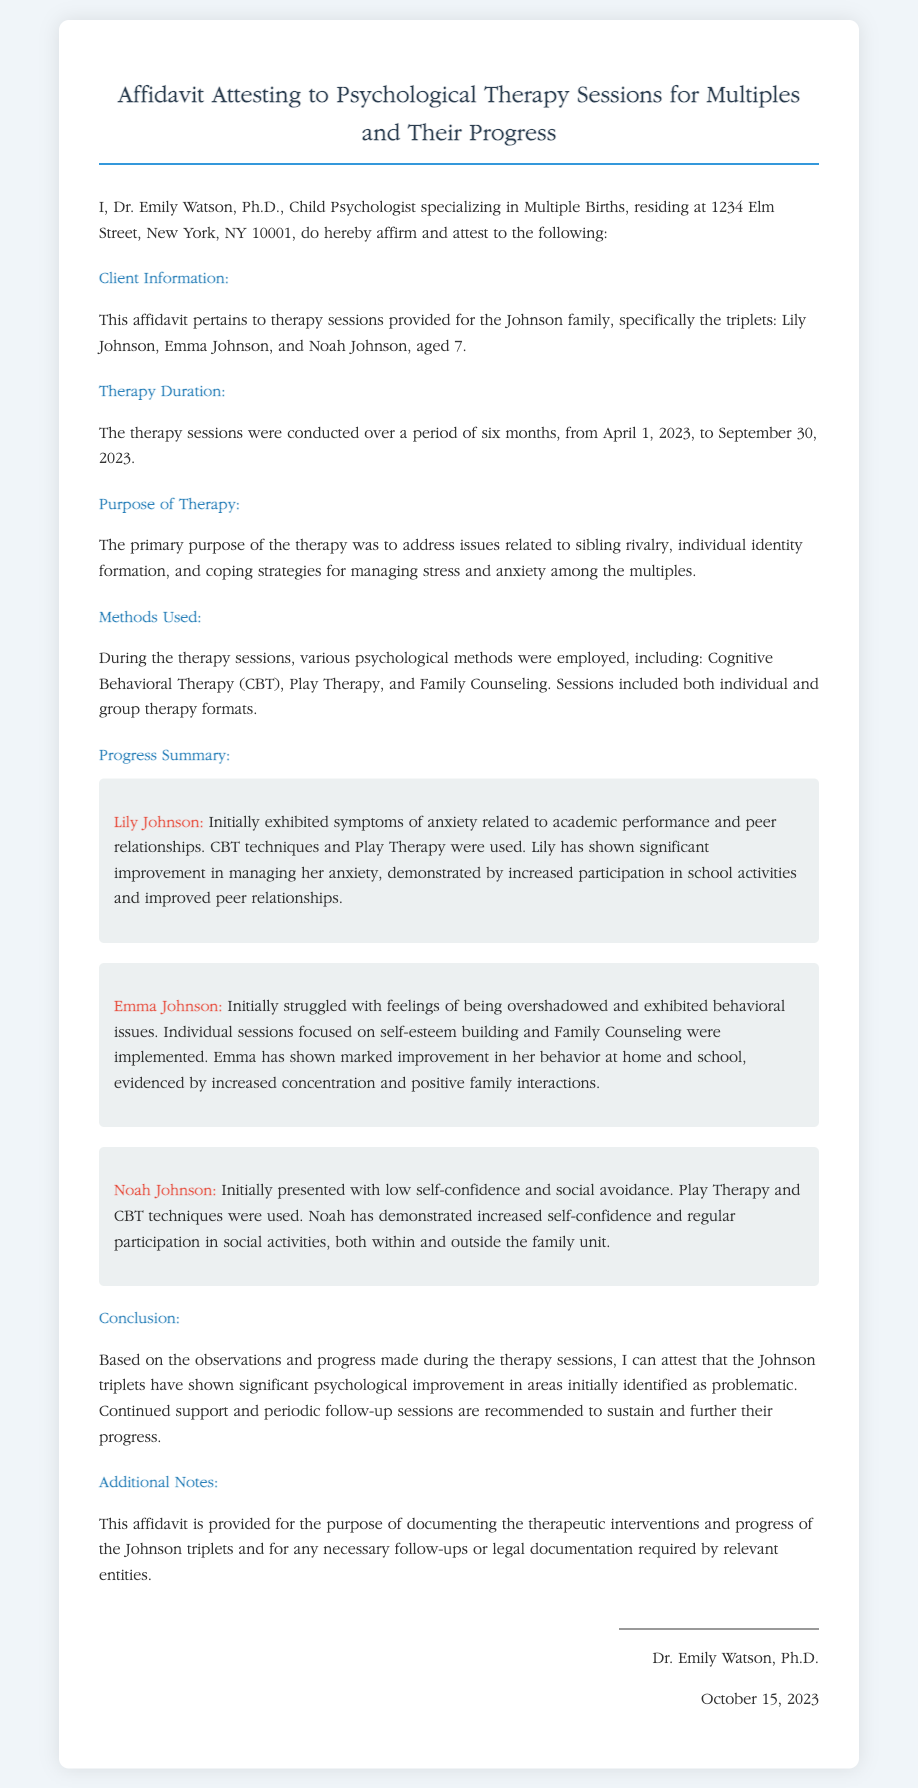What is the name of the psychologist? The psychologist's name is mentioned in the document as Dr. Emily Watson.
Answer: Dr. Emily Watson What are the names of the triplets? The triplets' names listed in the document are Lily Johnson, Emma Johnson, and Noah Johnson.
Answer: Lily Johnson, Emma Johnson, and Noah Johnson How long did the therapy last? The therapy duration stated in the document is six months.
Answer: six months What therapy method was used for Noah Johnson? The document specifies that Play Therapy and CBT techniques were used for Noah Johnson.
Answer: Play Therapy and CBT techniques What was a common issue addressed in the therapy? The document mentions sibling rivalry as one of the issues addressed in the therapy sessions.
Answer: sibling rivalry When did the therapy sessions start? The starting date of the therapy sessions is provided as April 1, 2023.
Answer: April 1, 2023 What does the affidavit recommend for the triplets' further progress? The document recommends continued support and periodic follow-up sessions for the triplets' further progress.
Answer: continued support and periodic follow-up sessions What is the purpose of this affidavit? The purpose of the affidavit, as stated in the document, is to document the therapeutic interventions and progress of the Johnson triplets.
Answer: document the therapeutic interventions and progress What was the conclusion about the triplets' psychological improvement? The document concludes that the Johnson triplets have shown significant psychological improvement.
Answer: significant psychological improvement 